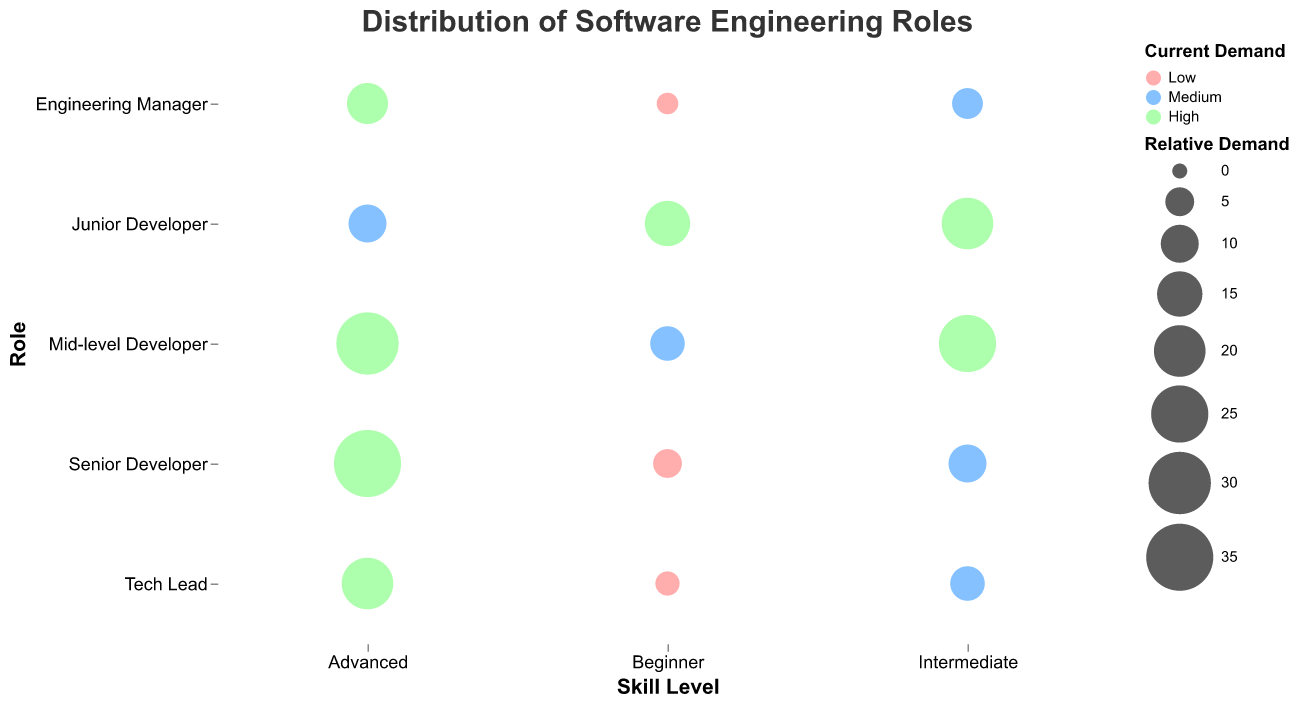What is the title of the figure? The title of the figure is usually displayed prominently at the top. Here, it reads "Distribution of Software Engineering Roles Based on Skill Levels and Current Demand in the Tech Industry".
Answer: Distribution of Software Engineering Roles Which role has the highest relative demand for advanced skill level? By observing the bubbles' size and color, we see that the largest bubble with a green color (indicating high demand) at the Advanced skill level corresponds to "Senior Developer."
Answer: Senior Developer What is the relative demand size for Mid-level Developers with intermediate skill level? The bubble's size for Mid-level Developers at the Intermediate skill level is represented as 25, as shown in the tooltip when hovering over that bubble.
Answer: 25 How many roles have low current demand across all skill levels? Look at the bubbles colored in red to signify low current demand and count their number across the chart. There are 3 such bubbles for "Senior Developer", "Tech Lead", and "Engineering Manager" at the Beginner level.
Answer: 3 Compare the current demand for Junior Developers at beginner and advanced skill levels. Which is higher? By comparing the colors of the bubbles, the Junior Developers at the Beginner skill level have a green bubble indicating high demand, while at Advanced skill level, it is a blue bubble indicating medium demand.
Answer: Beginner What is the role and skill level with the smallest relative demand size? Look for the smallest bubble in the plot. The smallest is the bubble with size 2 for "Engineering Manager" at the Beginner level.
Answer: Engineering Manager, Beginner How does the relative demand size vary between Mid-level Developers with advanced skill and Tech Leads with advanced skill? Compare the bubbles for Mid-level Developers and Tech Leads with advanced skill level. Mid-level Developer has a size 30 while Tech Lead has a size 20 as indicated by the tooltip.
Answer: Mid-level Developer has a larger demand size What is the current demand for Engineering Managers with intermediate skill level? By looking at both the color and size of the bubble for Engineering Managers at the Intermediate skill level, the color is blue which indicates medium demand.
Answer: Medium What can you say about the demand for roles with beginner skill level? Summarize observations of bubbles in the Beginner skill level column. Most roles like Senior Developer, Tech Lead, and Engineering Manager show low demand (red bubbles), while Junior Developers have high demand (green bubble).
Answer: Mostly low demand except for Junior Developers 